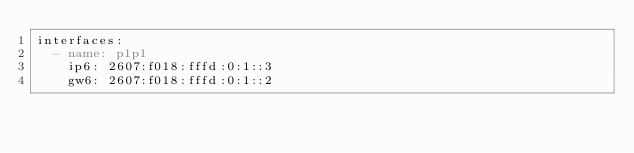<code> <loc_0><loc_0><loc_500><loc_500><_YAML_>interfaces:
  - name: p1p1
    ip6: 2607:f018:fffd:0:1::3
    gw6: 2607:f018:fffd:0:1::2
</code> 